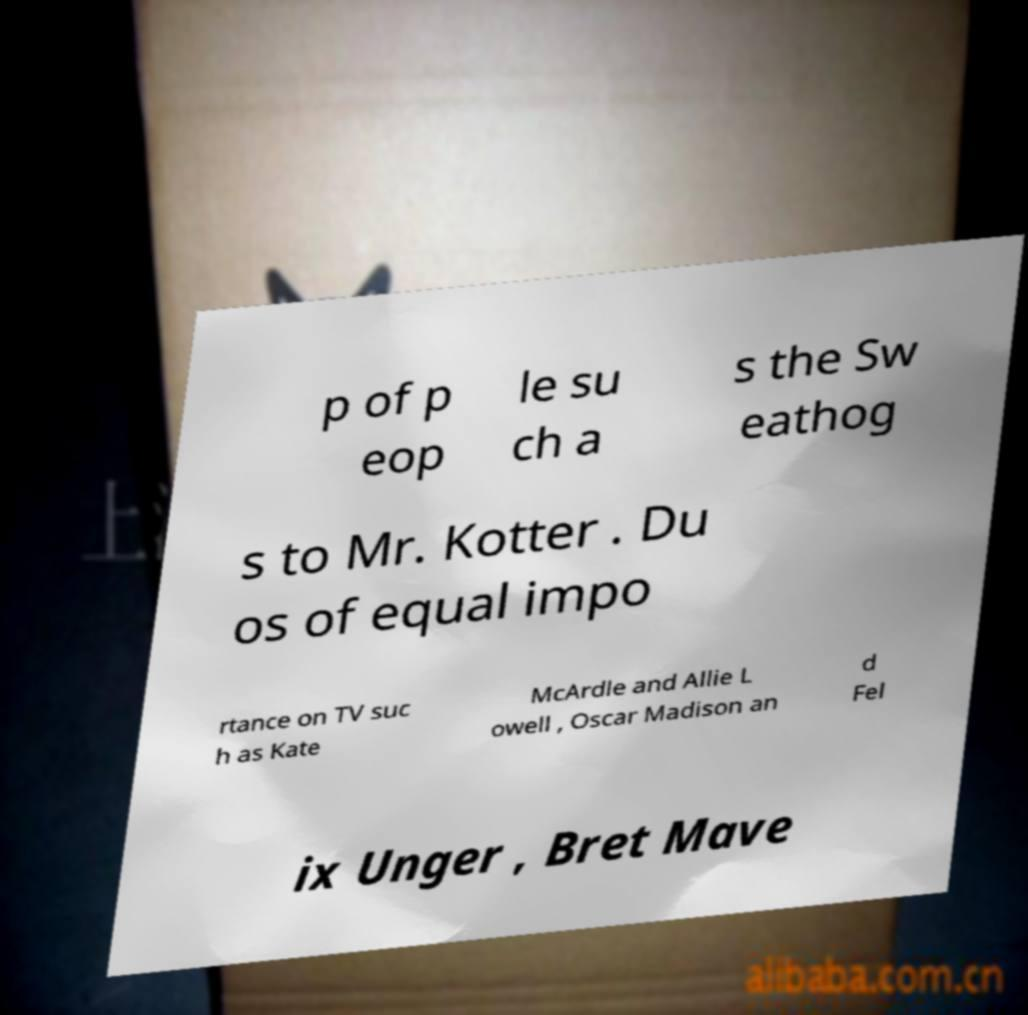Can you read and provide the text displayed in the image?This photo seems to have some interesting text. Can you extract and type it out for me? p of p eop le su ch a s the Sw eathog s to Mr. Kotter . Du os of equal impo rtance on TV suc h as Kate McArdle and Allie L owell , Oscar Madison an d Fel ix Unger , Bret Mave 